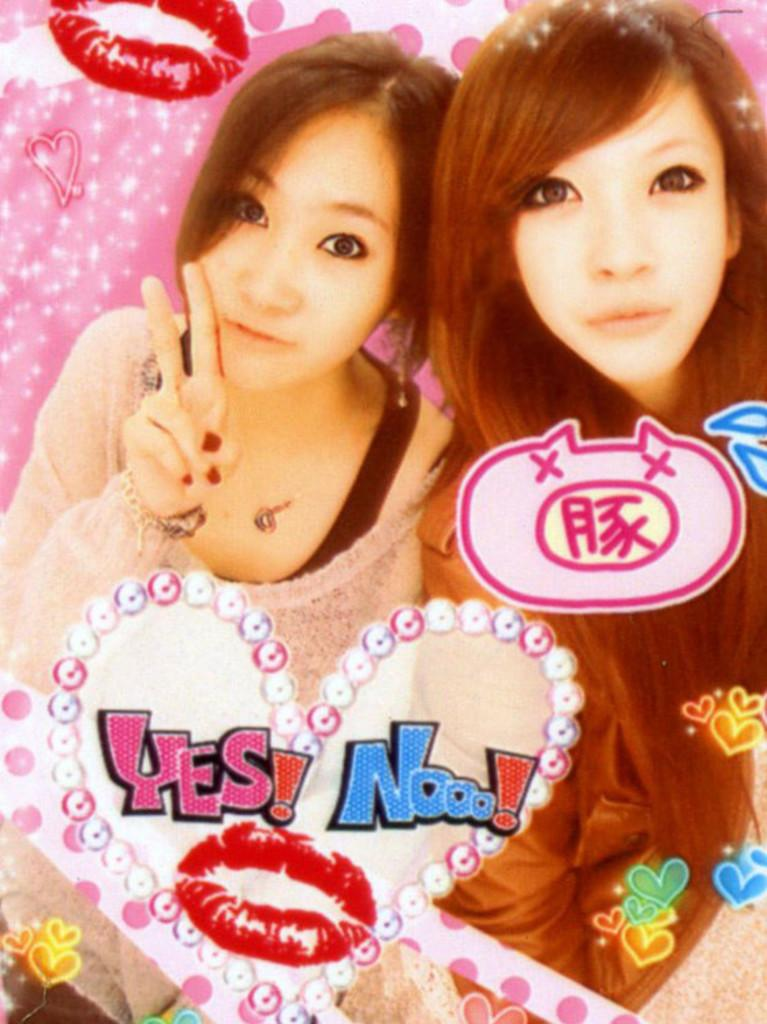What is the person in the image doing? The person is sitting at a desk. What object is in front of the person? There is a computer in front of them. Is the person driving a car in the image? No, the person is sitting at a desk, not driving a car. 